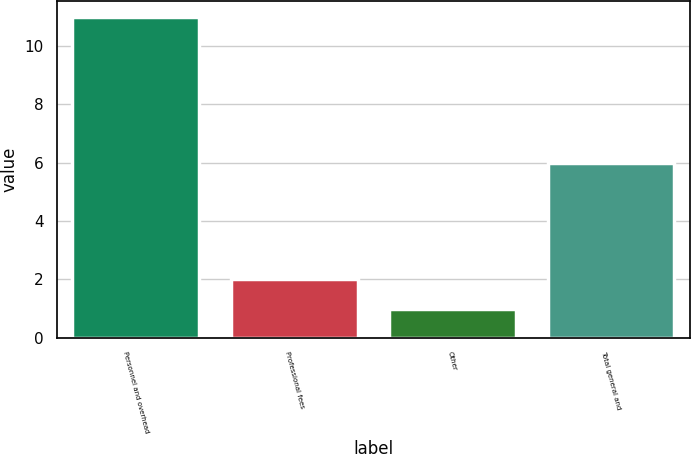<chart> <loc_0><loc_0><loc_500><loc_500><bar_chart><fcel>Personnel and overhead<fcel>Professional fees<fcel>Other<fcel>Total general and<nl><fcel>11<fcel>2<fcel>1<fcel>6<nl></chart> 